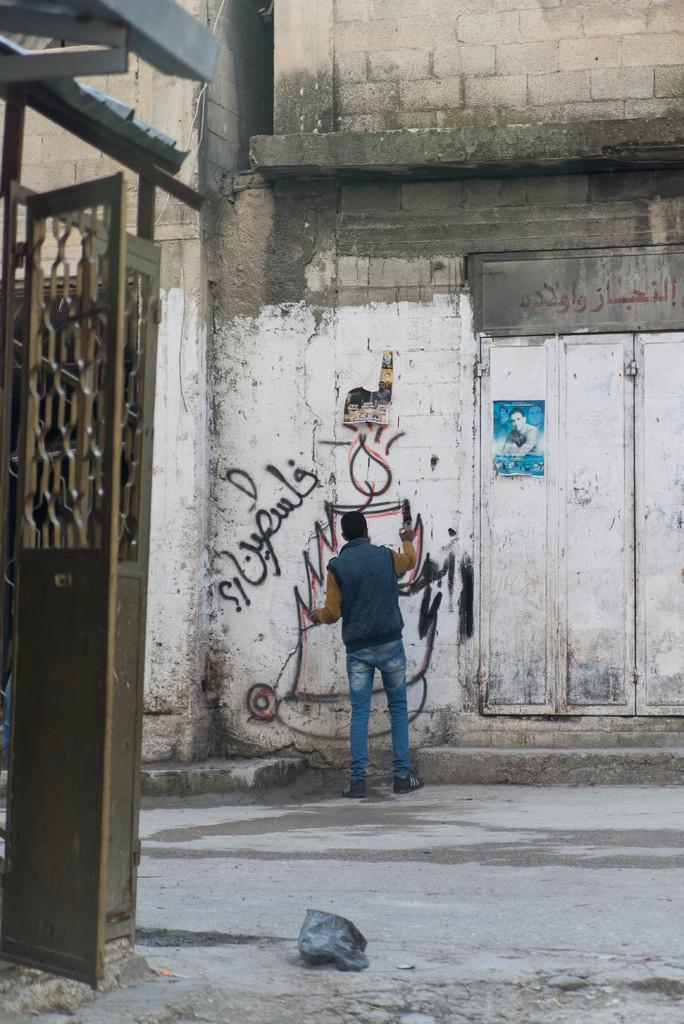What structure is located on the left side of the image? There is a gate on the left side of the image. What activity is taking place in the background of the image? There is a person doing graffiti on a wall in the background of the image. What can be seen at the bottom of the image? There is a road visible at the bottom of the image. How many rings does the person doing graffiti have on their fingers in the image? There is no information about rings on the person's fingers in the image. What type of chess pieces can be seen on the road in the image? There are no chess pieces visible on the road in the image. 